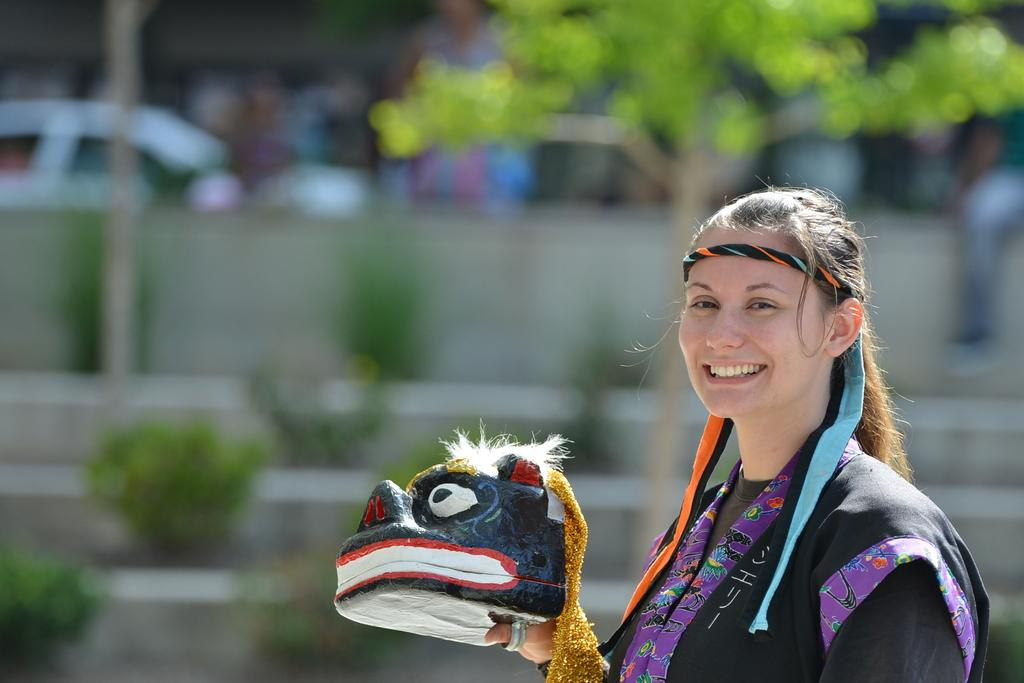Who is present in the image? There is a woman in the image. What is the woman wearing? The woman is wearing a dress and a headband. What is the woman holding in her hand? The woman is holding a toy in her hand. What can be seen in the background of the image? There are vehicles, a group of plants, and a tree in the background of the image. What type of fruit is the woman eating in the image? There is no fruit present in the image, and the woman is not eating anything. Where is the office located in the image? There is no office present in the image. 